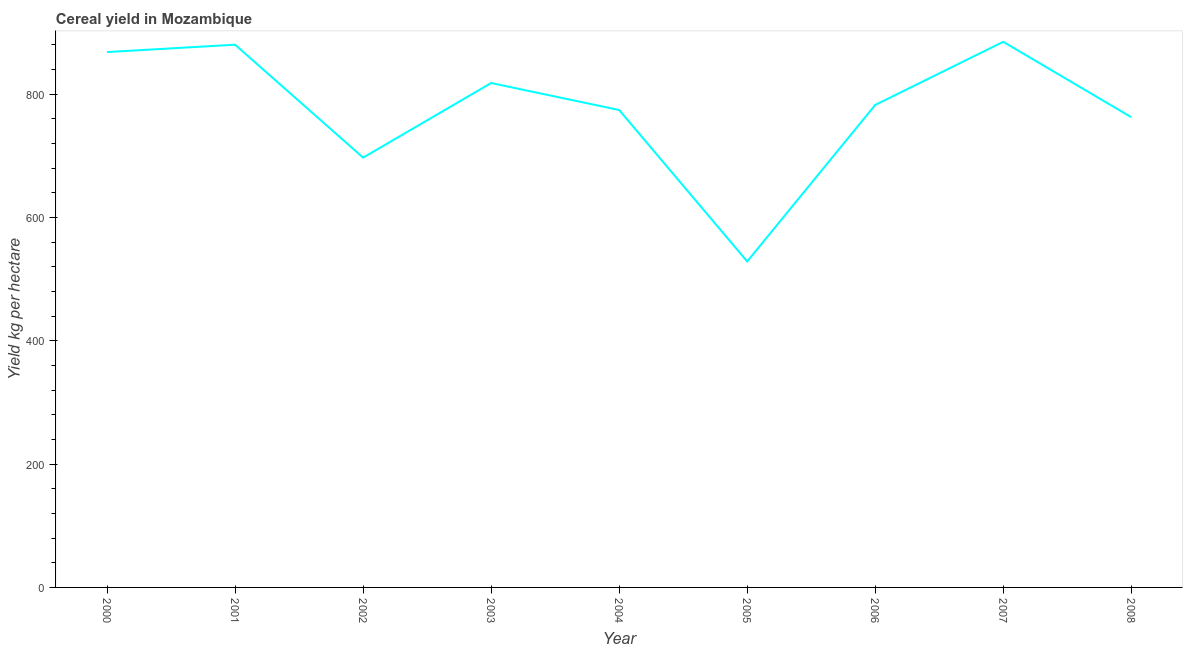What is the cereal yield in 2005?
Give a very brief answer. 528.6. Across all years, what is the maximum cereal yield?
Your answer should be compact. 884.75. Across all years, what is the minimum cereal yield?
Make the answer very short. 528.6. What is the sum of the cereal yield?
Your answer should be very brief. 6995.48. What is the difference between the cereal yield in 2003 and 2006?
Your answer should be compact. 35.55. What is the average cereal yield per year?
Ensure brevity in your answer.  777.28. What is the median cereal yield?
Offer a terse response. 782.38. Do a majority of the years between 2003 and 2005 (inclusive) have cereal yield greater than 600 kg per hectare?
Make the answer very short. Yes. What is the ratio of the cereal yield in 2004 to that in 2006?
Provide a short and direct response. 0.99. What is the difference between the highest and the second highest cereal yield?
Offer a very short reply. 4.69. What is the difference between the highest and the lowest cereal yield?
Your response must be concise. 356.15. How many years are there in the graph?
Offer a very short reply. 9. What is the difference between two consecutive major ticks on the Y-axis?
Offer a terse response. 200. Are the values on the major ticks of Y-axis written in scientific E-notation?
Make the answer very short. No. Does the graph contain grids?
Provide a short and direct response. No. What is the title of the graph?
Keep it short and to the point. Cereal yield in Mozambique. What is the label or title of the Y-axis?
Offer a terse response. Yield kg per hectare. What is the Yield kg per hectare of 2000?
Make the answer very short. 868.14. What is the Yield kg per hectare of 2001?
Your answer should be compact. 880.06. What is the Yield kg per hectare of 2002?
Your response must be concise. 696.94. What is the Yield kg per hectare of 2003?
Your answer should be compact. 817.92. What is the Yield kg per hectare in 2004?
Ensure brevity in your answer.  774.17. What is the Yield kg per hectare of 2005?
Make the answer very short. 528.6. What is the Yield kg per hectare in 2006?
Make the answer very short. 782.38. What is the Yield kg per hectare of 2007?
Offer a terse response. 884.75. What is the Yield kg per hectare of 2008?
Make the answer very short. 762.52. What is the difference between the Yield kg per hectare in 2000 and 2001?
Offer a very short reply. -11.93. What is the difference between the Yield kg per hectare in 2000 and 2002?
Your answer should be very brief. 171.2. What is the difference between the Yield kg per hectare in 2000 and 2003?
Your answer should be compact. 50.22. What is the difference between the Yield kg per hectare in 2000 and 2004?
Ensure brevity in your answer.  93.97. What is the difference between the Yield kg per hectare in 2000 and 2005?
Keep it short and to the point. 339.54. What is the difference between the Yield kg per hectare in 2000 and 2006?
Offer a very short reply. 85.76. What is the difference between the Yield kg per hectare in 2000 and 2007?
Your answer should be compact. -16.61. What is the difference between the Yield kg per hectare in 2000 and 2008?
Offer a very short reply. 105.62. What is the difference between the Yield kg per hectare in 2001 and 2002?
Offer a very short reply. 183.12. What is the difference between the Yield kg per hectare in 2001 and 2003?
Make the answer very short. 62.14. What is the difference between the Yield kg per hectare in 2001 and 2004?
Provide a short and direct response. 105.89. What is the difference between the Yield kg per hectare in 2001 and 2005?
Make the answer very short. 351.46. What is the difference between the Yield kg per hectare in 2001 and 2006?
Offer a very short reply. 97.69. What is the difference between the Yield kg per hectare in 2001 and 2007?
Give a very brief answer. -4.69. What is the difference between the Yield kg per hectare in 2001 and 2008?
Offer a terse response. 117.54. What is the difference between the Yield kg per hectare in 2002 and 2003?
Your response must be concise. -120.98. What is the difference between the Yield kg per hectare in 2002 and 2004?
Your response must be concise. -77.23. What is the difference between the Yield kg per hectare in 2002 and 2005?
Your response must be concise. 168.34. What is the difference between the Yield kg per hectare in 2002 and 2006?
Provide a succinct answer. -85.44. What is the difference between the Yield kg per hectare in 2002 and 2007?
Keep it short and to the point. -187.81. What is the difference between the Yield kg per hectare in 2002 and 2008?
Offer a terse response. -65.58. What is the difference between the Yield kg per hectare in 2003 and 2004?
Keep it short and to the point. 43.76. What is the difference between the Yield kg per hectare in 2003 and 2005?
Your answer should be very brief. 289.32. What is the difference between the Yield kg per hectare in 2003 and 2006?
Your answer should be compact. 35.55. What is the difference between the Yield kg per hectare in 2003 and 2007?
Your answer should be compact. -66.83. What is the difference between the Yield kg per hectare in 2003 and 2008?
Provide a short and direct response. 55.4. What is the difference between the Yield kg per hectare in 2004 and 2005?
Provide a short and direct response. 245.57. What is the difference between the Yield kg per hectare in 2004 and 2006?
Your answer should be compact. -8.21. What is the difference between the Yield kg per hectare in 2004 and 2007?
Ensure brevity in your answer.  -110.58. What is the difference between the Yield kg per hectare in 2004 and 2008?
Ensure brevity in your answer.  11.65. What is the difference between the Yield kg per hectare in 2005 and 2006?
Your response must be concise. -253.78. What is the difference between the Yield kg per hectare in 2005 and 2007?
Offer a terse response. -356.15. What is the difference between the Yield kg per hectare in 2005 and 2008?
Give a very brief answer. -233.92. What is the difference between the Yield kg per hectare in 2006 and 2007?
Offer a terse response. -102.38. What is the difference between the Yield kg per hectare in 2006 and 2008?
Your answer should be compact. 19.86. What is the difference between the Yield kg per hectare in 2007 and 2008?
Ensure brevity in your answer.  122.23. What is the ratio of the Yield kg per hectare in 2000 to that in 2002?
Provide a succinct answer. 1.25. What is the ratio of the Yield kg per hectare in 2000 to that in 2003?
Your answer should be very brief. 1.06. What is the ratio of the Yield kg per hectare in 2000 to that in 2004?
Provide a short and direct response. 1.12. What is the ratio of the Yield kg per hectare in 2000 to that in 2005?
Ensure brevity in your answer.  1.64. What is the ratio of the Yield kg per hectare in 2000 to that in 2006?
Offer a terse response. 1.11. What is the ratio of the Yield kg per hectare in 2000 to that in 2007?
Make the answer very short. 0.98. What is the ratio of the Yield kg per hectare in 2000 to that in 2008?
Your answer should be very brief. 1.14. What is the ratio of the Yield kg per hectare in 2001 to that in 2002?
Make the answer very short. 1.26. What is the ratio of the Yield kg per hectare in 2001 to that in 2003?
Your response must be concise. 1.08. What is the ratio of the Yield kg per hectare in 2001 to that in 2004?
Your answer should be very brief. 1.14. What is the ratio of the Yield kg per hectare in 2001 to that in 2005?
Offer a terse response. 1.67. What is the ratio of the Yield kg per hectare in 2001 to that in 2008?
Give a very brief answer. 1.15. What is the ratio of the Yield kg per hectare in 2002 to that in 2003?
Give a very brief answer. 0.85. What is the ratio of the Yield kg per hectare in 2002 to that in 2004?
Keep it short and to the point. 0.9. What is the ratio of the Yield kg per hectare in 2002 to that in 2005?
Give a very brief answer. 1.32. What is the ratio of the Yield kg per hectare in 2002 to that in 2006?
Your response must be concise. 0.89. What is the ratio of the Yield kg per hectare in 2002 to that in 2007?
Make the answer very short. 0.79. What is the ratio of the Yield kg per hectare in 2002 to that in 2008?
Provide a succinct answer. 0.91. What is the ratio of the Yield kg per hectare in 2003 to that in 2004?
Give a very brief answer. 1.06. What is the ratio of the Yield kg per hectare in 2003 to that in 2005?
Give a very brief answer. 1.55. What is the ratio of the Yield kg per hectare in 2003 to that in 2006?
Your response must be concise. 1.04. What is the ratio of the Yield kg per hectare in 2003 to that in 2007?
Offer a terse response. 0.92. What is the ratio of the Yield kg per hectare in 2003 to that in 2008?
Your response must be concise. 1.07. What is the ratio of the Yield kg per hectare in 2004 to that in 2005?
Offer a very short reply. 1.47. What is the ratio of the Yield kg per hectare in 2004 to that in 2006?
Give a very brief answer. 0.99. What is the ratio of the Yield kg per hectare in 2004 to that in 2007?
Make the answer very short. 0.88. What is the ratio of the Yield kg per hectare in 2004 to that in 2008?
Provide a short and direct response. 1.01. What is the ratio of the Yield kg per hectare in 2005 to that in 2006?
Provide a succinct answer. 0.68. What is the ratio of the Yield kg per hectare in 2005 to that in 2007?
Your response must be concise. 0.6. What is the ratio of the Yield kg per hectare in 2005 to that in 2008?
Your answer should be compact. 0.69. What is the ratio of the Yield kg per hectare in 2006 to that in 2007?
Your answer should be very brief. 0.88. What is the ratio of the Yield kg per hectare in 2007 to that in 2008?
Give a very brief answer. 1.16. 